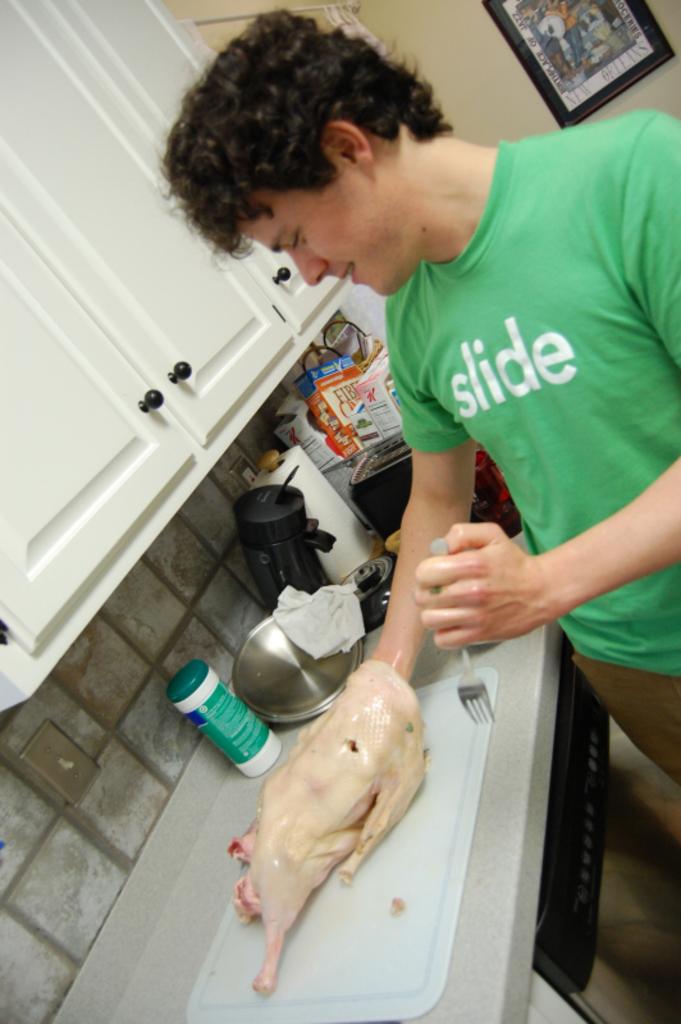What does the mans green shirt read?
Offer a very short reply. Slide. 